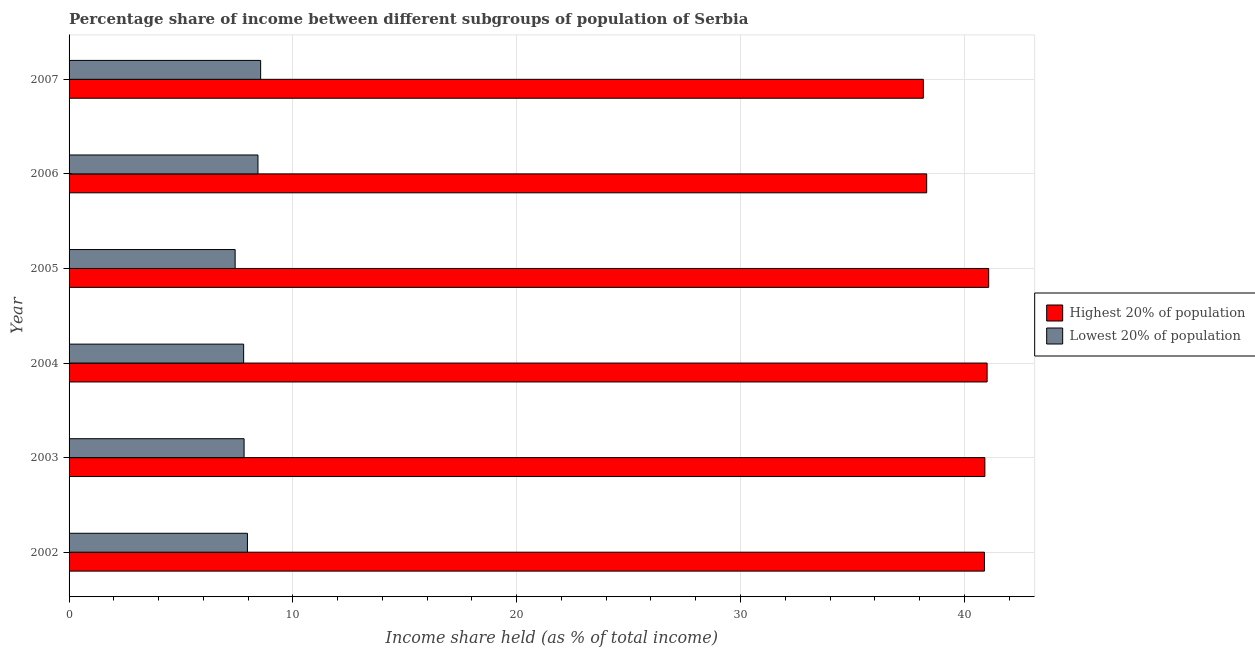How many groups of bars are there?
Provide a succinct answer. 6. Are the number of bars per tick equal to the number of legend labels?
Your answer should be very brief. Yes. Are the number of bars on each tick of the Y-axis equal?
Offer a very short reply. Yes. How many bars are there on the 6th tick from the bottom?
Your answer should be very brief. 2. What is the income share held by highest 20% of the population in 2003?
Offer a terse response. 40.92. Across all years, what is the maximum income share held by highest 20% of the population?
Provide a succinct answer. 41.09. Across all years, what is the minimum income share held by lowest 20% of the population?
Ensure brevity in your answer.  7.42. In which year was the income share held by lowest 20% of the population minimum?
Offer a very short reply. 2005. What is the total income share held by highest 20% of the population in the graph?
Your response must be concise. 240.42. What is the difference between the income share held by highest 20% of the population in 2005 and that in 2006?
Provide a short and direct response. 2.77. What is the difference between the income share held by lowest 20% of the population in 2002 and the income share held by highest 20% of the population in 2003?
Your response must be concise. -32.95. What is the average income share held by lowest 20% of the population per year?
Your answer should be compact. 8. In the year 2005, what is the difference between the income share held by highest 20% of the population and income share held by lowest 20% of the population?
Offer a very short reply. 33.67. In how many years, is the income share held by lowest 20% of the population greater than 30 %?
Keep it short and to the point. 0. What is the ratio of the income share held by lowest 20% of the population in 2003 to that in 2005?
Your answer should be very brief. 1.05. What is the difference between the highest and the second highest income share held by lowest 20% of the population?
Keep it short and to the point. 0.12. What is the difference between the highest and the lowest income share held by lowest 20% of the population?
Provide a short and direct response. 1.14. Is the sum of the income share held by highest 20% of the population in 2005 and 2007 greater than the maximum income share held by lowest 20% of the population across all years?
Offer a terse response. Yes. What does the 2nd bar from the top in 2004 represents?
Your answer should be compact. Highest 20% of population. What does the 1st bar from the bottom in 2005 represents?
Offer a terse response. Highest 20% of population. How many bars are there?
Provide a short and direct response. 12. Are all the bars in the graph horizontal?
Provide a short and direct response. Yes. Are the values on the major ticks of X-axis written in scientific E-notation?
Ensure brevity in your answer.  No. Does the graph contain grids?
Your answer should be very brief. Yes. What is the title of the graph?
Keep it short and to the point. Percentage share of income between different subgroups of population of Serbia. What is the label or title of the X-axis?
Give a very brief answer. Income share held (as % of total income). What is the label or title of the Y-axis?
Your response must be concise. Year. What is the Income share held (as % of total income) in Highest 20% of population in 2002?
Your response must be concise. 40.9. What is the Income share held (as % of total income) in Lowest 20% of population in 2002?
Keep it short and to the point. 7.97. What is the Income share held (as % of total income) in Highest 20% of population in 2003?
Your answer should be very brief. 40.92. What is the Income share held (as % of total income) in Lowest 20% of population in 2003?
Provide a short and direct response. 7.82. What is the Income share held (as % of total income) of Highest 20% of population in 2004?
Your answer should be very brief. 41.02. What is the Income share held (as % of total income) in Lowest 20% of population in 2004?
Your response must be concise. 7.8. What is the Income share held (as % of total income) of Highest 20% of population in 2005?
Make the answer very short. 41.09. What is the Income share held (as % of total income) in Lowest 20% of population in 2005?
Offer a terse response. 7.42. What is the Income share held (as % of total income) of Highest 20% of population in 2006?
Give a very brief answer. 38.32. What is the Income share held (as % of total income) of Lowest 20% of population in 2006?
Provide a succinct answer. 8.44. What is the Income share held (as % of total income) of Highest 20% of population in 2007?
Make the answer very short. 38.17. What is the Income share held (as % of total income) of Lowest 20% of population in 2007?
Ensure brevity in your answer.  8.56. Across all years, what is the maximum Income share held (as % of total income) of Highest 20% of population?
Offer a very short reply. 41.09. Across all years, what is the maximum Income share held (as % of total income) of Lowest 20% of population?
Provide a succinct answer. 8.56. Across all years, what is the minimum Income share held (as % of total income) in Highest 20% of population?
Your answer should be compact. 38.17. Across all years, what is the minimum Income share held (as % of total income) of Lowest 20% of population?
Your response must be concise. 7.42. What is the total Income share held (as % of total income) of Highest 20% of population in the graph?
Give a very brief answer. 240.42. What is the total Income share held (as % of total income) of Lowest 20% of population in the graph?
Ensure brevity in your answer.  48.01. What is the difference between the Income share held (as % of total income) in Highest 20% of population in 2002 and that in 2003?
Your answer should be very brief. -0.02. What is the difference between the Income share held (as % of total income) in Highest 20% of population in 2002 and that in 2004?
Offer a very short reply. -0.12. What is the difference between the Income share held (as % of total income) in Lowest 20% of population in 2002 and that in 2004?
Your answer should be compact. 0.17. What is the difference between the Income share held (as % of total income) in Highest 20% of population in 2002 and that in 2005?
Your answer should be compact. -0.19. What is the difference between the Income share held (as % of total income) of Lowest 20% of population in 2002 and that in 2005?
Keep it short and to the point. 0.55. What is the difference between the Income share held (as % of total income) of Highest 20% of population in 2002 and that in 2006?
Ensure brevity in your answer.  2.58. What is the difference between the Income share held (as % of total income) in Lowest 20% of population in 2002 and that in 2006?
Your answer should be compact. -0.47. What is the difference between the Income share held (as % of total income) in Highest 20% of population in 2002 and that in 2007?
Offer a very short reply. 2.73. What is the difference between the Income share held (as % of total income) of Lowest 20% of population in 2002 and that in 2007?
Your answer should be compact. -0.59. What is the difference between the Income share held (as % of total income) of Highest 20% of population in 2003 and that in 2005?
Ensure brevity in your answer.  -0.17. What is the difference between the Income share held (as % of total income) in Lowest 20% of population in 2003 and that in 2005?
Your answer should be compact. 0.4. What is the difference between the Income share held (as % of total income) in Lowest 20% of population in 2003 and that in 2006?
Offer a terse response. -0.62. What is the difference between the Income share held (as % of total income) in Highest 20% of population in 2003 and that in 2007?
Ensure brevity in your answer.  2.75. What is the difference between the Income share held (as % of total income) of Lowest 20% of population in 2003 and that in 2007?
Your answer should be compact. -0.74. What is the difference between the Income share held (as % of total income) in Highest 20% of population in 2004 and that in 2005?
Provide a short and direct response. -0.07. What is the difference between the Income share held (as % of total income) of Lowest 20% of population in 2004 and that in 2005?
Keep it short and to the point. 0.38. What is the difference between the Income share held (as % of total income) of Lowest 20% of population in 2004 and that in 2006?
Your answer should be compact. -0.64. What is the difference between the Income share held (as % of total income) in Highest 20% of population in 2004 and that in 2007?
Your answer should be compact. 2.85. What is the difference between the Income share held (as % of total income) of Lowest 20% of population in 2004 and that in 2007?
Your response must be concise. -0.76. What is the difference between the Income share held (as % of total income) of Highest 20% of population in 2005 and that in 2006?
Offer a very short reply. 2.77. What is the difference between the Income share held (as % of total income) in Lowest 20% of population in 2005 and that in 2006?
Provide a succinct answer. -1.02. What is the difference between the Income share held (as % of total income) in Highest 20% of population in 2005 and that in 2007?
Provide a succinct answer. 2.92. What is the difference between the Income share held (as % of total income) of Lowest 20% of population in 2005 and that in 2007?
Ensure brevity in your answer.  -1.14. What is the difference between the Income share held (as % of total income) of Lowest 20% of population in 2006 and that in 2007?
Keep it short and to the point. -0.12. What is the difference between the Income share held (as % of total income) of Highest 20% of population in 2002 and the Income share held (as % of total income) of Lowest 20% of population in 2003?
Offer a terse response. 33.08. What is the difference between the Income share held (as % of total income) in Highest 20% of population in 2002 and the Income share held (as % of total income) in Lowest 20% of population in 2004?
Your answer should be compact. 33.1. What is the difference between the Income share held (as % of total income) of Highest 20% of population in 2002 and the Income share held (as % of total income) of Lowest 20% of population in 2005?
Your answer should be compact. 33.48. What is the difference between the Income share held (as % of total income) of Highest 20% of population in 2002 and the Income share held (as % of total income) of Lowest 20% of population in 2006?
Keep it short and to the point. 32.46. What is the difference between the Income share held (as % of total income) of Highest 20% of population in 2002 and the Income share held (as % of total income) of Lowest 20% of population in 2007?
Give a very brief answer. 32.34. What is the difference between the Income share held (as % of total income) in Highest 20% of population in 2003 and the Income share held (as % of total income) in Lowest 20% of population in 2004?
Offer a terse response. 33.12. What is the difference between the Income share held (as % of total income) in Highest 20% of population in 2003 and the Income share held (as % of total income) in Lowest 20% of population in 2005?
Offer a terse response. 33.5. What is the difference between the Income share held (as % of total income) in Highest 20% of population in 2003 and the Income share held (as % of total income) in Lowest 20% of population in 2006?
Keep it short and to the point. 32.48. What is the difference between the Income share held (as % of total income) of Highest 20% of population in 2003 and the Income share held (as % of total income) of Lowest 20% of population in 2007?
Your answer should be compact. 32.36. What is the difference between the Income share held (as % of total income) in Highest 20% of population in 2004 and the Income share held (as % of total income) in Lowest 20% of population in 2005?
Keep it short and to the point. 33.6. What is the difference between the Income share held (as % of total income) in Highest 20% of population in 2004 and the Income share held (as % of total income) in Lowest 20% of population in 2006?
Offer a very short reply. 32.58. What is the difference between the Income share held (as % of total income) in Highest 20% of population in 2004 and the Income share held (as % of total income) in Lowest 20% of population in 2007?
Provide a short and direct response. 32.46. What is the difference between the Income share held (as % of total income) of Highest 20% of population in 2005 and the Income share held (as % of total income) of Lowest 20% of population in 2006?
Provide a succinct answer. 32.65. What is the difference between the Income share held (as % of total income) of Highest 20% of population in 2005 and the Income share held (as % of total income) of Lowest 20% of population in 2007?
Your answer should be compact. 32.53. What is the difference between the Income share held (as % of total income) in Highest 20% of population in 2006 and the Income share held (as % of total income) in Lowest 20% of population in 2007?
Your answer should be compact. 29.76. What is the average Income share held (as % of total income) in Highest 20% of population per year?
Give a very brief answer. 40.07. What is the average Income share held (as % of total income) of Lowest 20% of population per year?
Your answer should be compact. 8. In the year 2002, what is the difference between the Income share held (as % of total income) in Highest 20% of population and Income share held (as % of total income) in Lowest 20% of population?
Offer a very short reply. 32.93. In the year 2003, what is the difference between the Income share held (as % of total income) in Highest 20% of population and Income share held (as % of total income) in Lowest 20% of population?
Provide a succinct answer. 33.1. In the year 2004, what is the difference between the Income share held (as % of total income) of Highest 20% of population and Income share held (as % of total income) of Lowest 20% of population?
Provide a succinct answer. 33.22. In the year 2005, what is the difference between the Income share held (as % of total income) of Highest 20% of population and Income share held (as % of total income) of Lowest 20% of population?
Ensure brevity in your answer.  33.67. In the year 2006, what is the difference between the Income share held (as % of total income) in Highest 20% of population and Income share held (as % of total income) in Lowest 20% of population?
Ensure brevity in your answer.  29.88. In the year 2007, what is the difference between the Income share held (as % of total income) in Highest 20% of population and Income share held (as % of total income) in Lowest 20% of population?
Your answer should be very brief. 29.61. What is the ratio of the Income share held (as % of total income) of Lowest 20% of population in 2002 to that in 2003?
Provide a succinct answer. 1.02. What is the ratio of the Income share held (as % of total income) in Lowest 20% of population in 2002 to that in 2004?
Your answer should be compact. 1.02. What is the ratio of the Income share held (as % of total income) of Highest 20% of population in 2002 to that in 2005?
Provide a short and direct response. 1. What is the ratio of the Income share held (as % of total income) in Lowest 20% of population in 2002 to that in 2005?
Your response must be concise. 1.07. What is the ratio of the Income share held (as % of total income) of Highest 20% of population in 2002 to that in 2006?
Offer a very short reply. 1.07. What is the ratio of the Income share held (as % of total income) of Lowest 20% of population in 2002 to that in 2006?
Give a very brief answer. 0.94. What is the ratio of the Income share held (as % of total income) in Highest 20% of population in 2002 to that in 2007?
Your answer should be very brief. 1.07. What is the ratio of the Income share held (as % of total income) of Lowest 20% of population in 2002 to that in 2007?
Keep it short and to the point. 0.93. What is the ratio of the Income share held (as % of total income) of Highest 20% of population in 2003 to that in 2005?
Make the answer very short. 1. What is the ratio of the Income share held (as % of total income) in Lowest 20% of population in 2003 to that in 2005?
Your answer should be very brief. 1.05. What is the ratio of the Income share held (as % of total income) of Highest 20% of population in 2003 to that in 2006?
Provide a short and direct response. 1.07. What is the ratio of the Income share held (as % of total income) of Lowest 20% of population in 2003 to that in 2006?
Your response must be concise. 0.93. What is the ratio of the Income share held (as % of total income) of Highest 20% of population in 2003 to that in 2007?
Keep it short and to the point. 1.07. What is the ratio of the Income share held (as % of total income) in Lowest 20% of population in 2003 to that in 2007?
Offer a very short reply. 0.91. What is the ratio of the Income share held (as % of total income) in Lowest 20% of population in 2004 to that in 2005?
Your response must be concise. 1.05. What is the ratio of the Income share held (as % of total income) in Highest 20% of population in 2004 to that in 2006?
Your answer should be very brief. 1.07. What is the ratio of the Income share held (as % of total income) in Lowest 20% of population in 2004 to that in 2006?
Ensure brevity in your answer.  0.92. What is the ratio of the Income share held (as % of total income) in Highest 20% of population in 2004 to that in 2007?
Give a very brief answer. 1.07. What is the ratio of the Income share held (as % of total income) of Lowest 20% of population in 2004 to that in 2007?
Offer a terse response. 0.91. What is the ratio of the Income share held (as % of total income) of Highest 20% of population in 2005 to that in 2006?
Offer a very short reply. 1.07. What is the ratio of the Income share held (as % of total income) in Lowest 20% of population in 2005 to that in 2006?
Offer a terse response. 0.88. What is the ratio of the Income share held (as % of total income) of Highest 20% of population in 2005 to that in 2007?
Offer a very short reply. 1.08. What is the ratio of the Income share held (as % of total income) of Lowest 20% of population in 2005 to that in 2007?
Offer a terse response. 0.87. What is the ratio of the Income share held (as % of total income) in Highest 20% of population in 2006 to that in 2007?
Offer a terse response. 1. What is the ratio of the Income share held (as % of total income) of Lowest 20% of population in 2006 to that in 2007?
Keep it short and to the point. 0.99. What is the difference between the highest and the second highest Income share held (as % of total income) of Highest 20% of population?
Provide a succinct answer. 0.07. What is the difference between the highest and the second highest Income share held (as % of total income) of Lowest 20% of population?
Keep it short and to the point. 0.12. What is the difference between the highest and the lowest Income share held (as % of total income) in Highest 20% of population?
Make the answer very short. 2.92. What is the difference between the highest and the lowest Income share held (as % of total income) of Lowest 20% of population?
Your answer should be very brief. 1.14. 